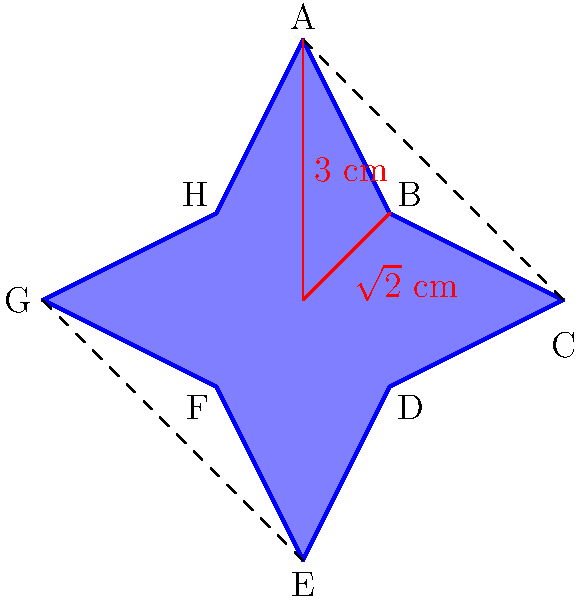A local police department in California is designing a new star-shaped badge. The badge is an 8-pointed star, as shown in the diagram. The distance from the center to each outer point (A, C, E, G) is 3 cm, and the distance from the center to each inner point (B, D, F, H) is $\sqrt{2}$ cm. Calculate the perimeter of the badge to the nearest centimeter. To calculate the perimeter, we need to find the length of each side and sum them up. There are 8 sides in total.

Step 1: Find the length of one side (e.g., AB) using the Pythagorean theorem.
$AB^2 = 3^2 + (\sqrt{2})^2 - 2(3)(\sqrt{2})\cos(45°)$
$AB^2 = 9 + 2 - 6\sqrt{2} \cdot \frac{\sqrt{2}}{2} = 11 - 6 = 5$
$AB = \sqrt{5}$ cm

Step 2: Calculate the perimeter by multiplying the length of one side by 8.
Perimeter $= 8 \cdot \sqrt{5}$ cm $\approx 17.89$ cm

Step 3: Round to the nearest centimeter.
Perimeter $\approx 18$ cm
Answer: 18 cm 